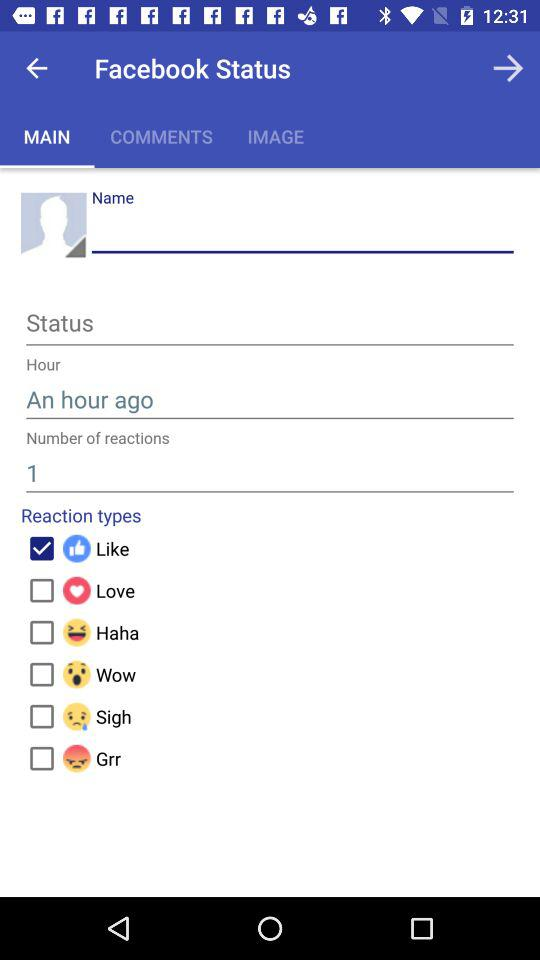What text is entered in "Hour"? The text entered in "Hour" is "An hour ago". 